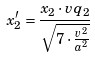<formula> <loc_0><loc_0><loc_500><loc_500>x _ { 2 } ^ { \prime } = \frac { x _ { 2 } \cdot v q _ { 2 } } { \sqrt { 7 \cdot \frac { v ^ { 2 } } { a ^ { 2 } } } }</formula> 